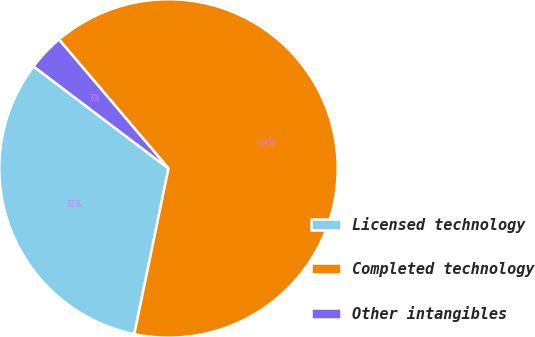Convert chart. <chart><loc_0><loc_0><loc_500><loc_500><pie_chart><fcel>Licensed technology<fcel>Completed technology<fcel>Other intangibles<nl><fcel>32.06%<fcel>64.44%<fcel>3.49%<nl></chart> 